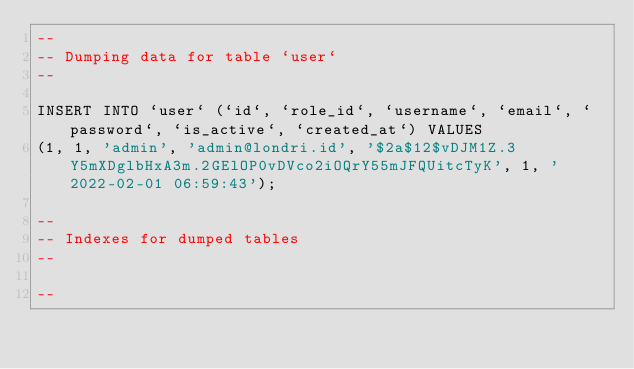<code> <loc_0><loc_0><loc_500><loc_500><_SQL_>--
-- Dumping data for table `user`
--

INSERT INTO `user` (`id`, `role_id`, `username`, `email`, `password`, `is_active`, `created_at`) VALUES
(1, 1, 'admin', 'admin@londri.id', '$2a$12$vDJM1Z.3Y5mXDglbHxA3m.2GElOP0vDVco2iOQrY55mJFQUitcTyK', 1, '2022-02-01 06:59:43');

--
-- Indexes for dumped tables
--

--</code> 